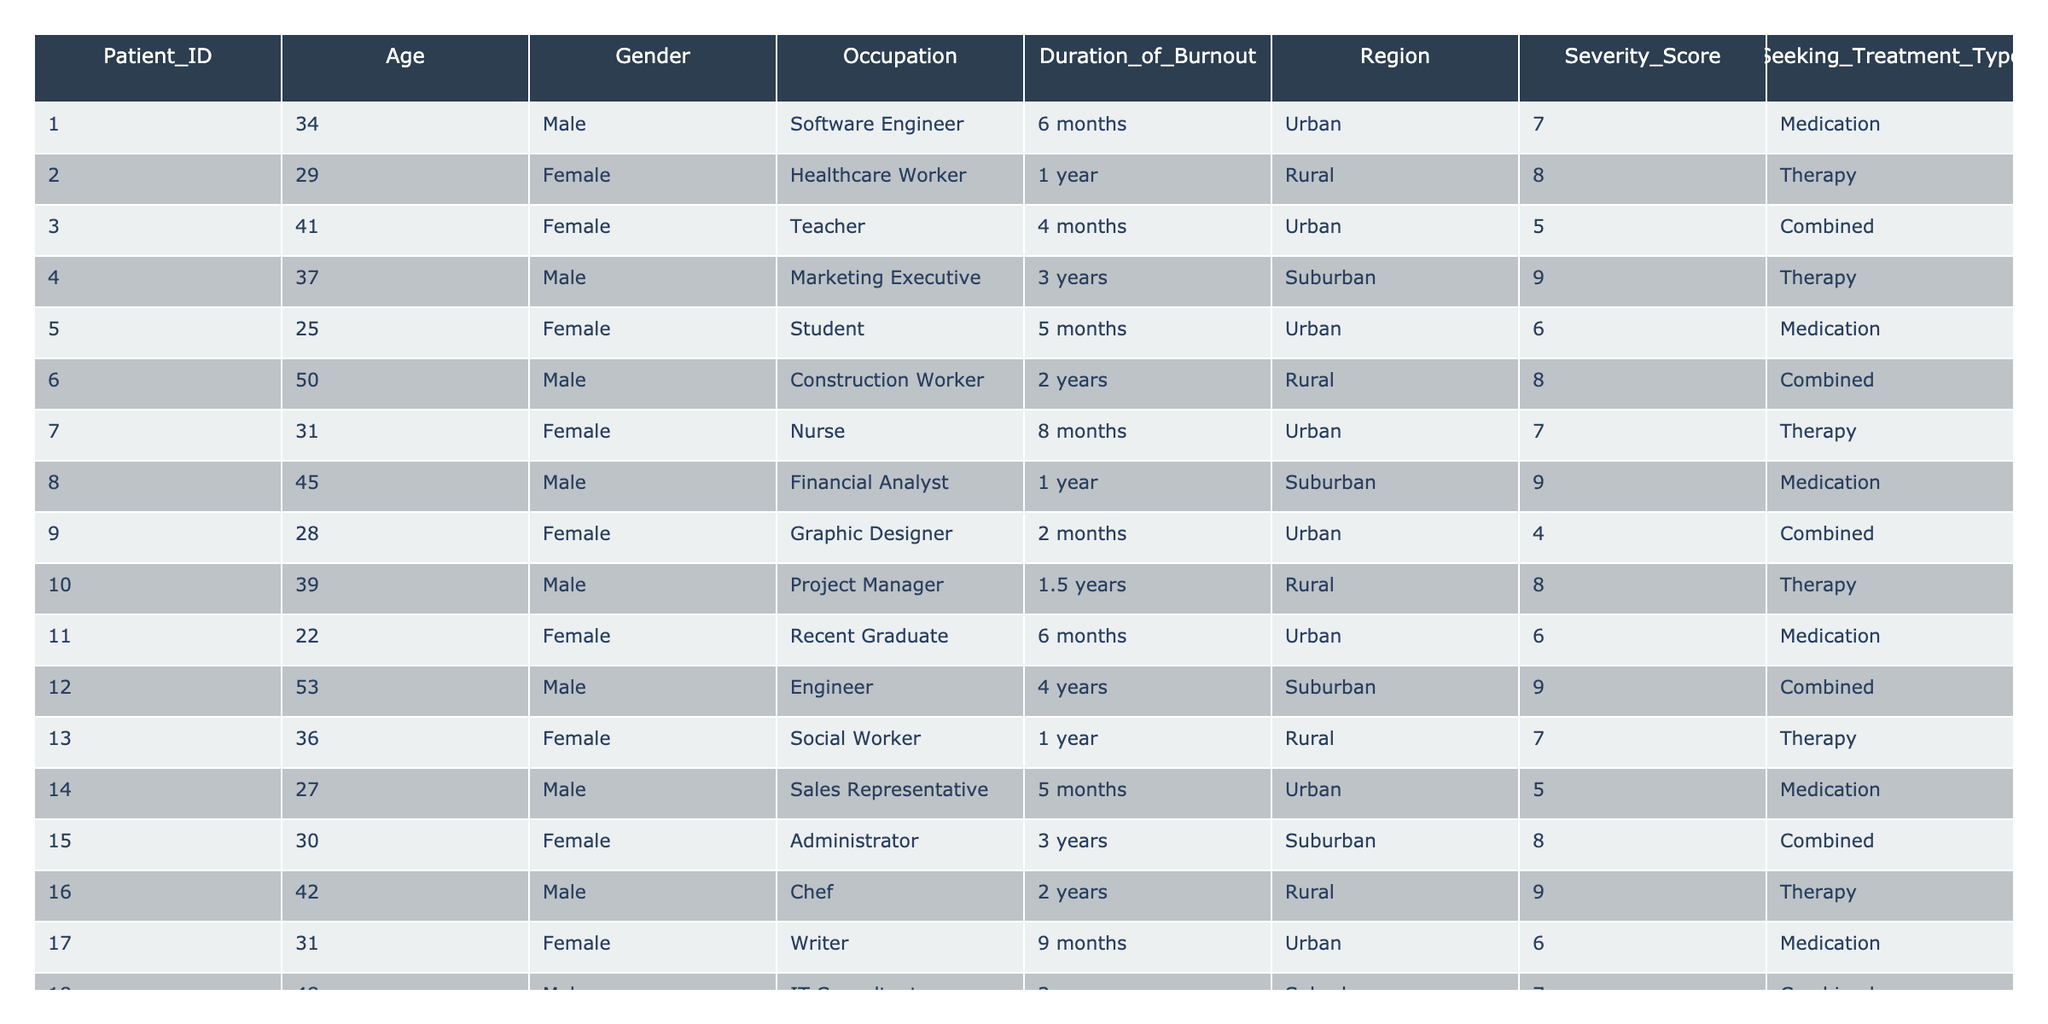What is the age of the youngest patient seeking treatment? The youngest patient is Patient_ID 11, who is 22 years old. I identified the ages in the table and determined that 22 is the lowest value.
Answer: 22 How many males are seeking medication for burnout? Looking at the table, Patients 1, 5, 14, 20 are the males listed under the 'Medication' treatment type, totaling 4 males.
Answer: 4 What is the average severity score of patients in suburban areas? The severity scores of patients from suburban areas are 9, 9, 8, 7, and 9. The average is calculated as (9 + 9 + 8 + 7 + 9) / 5 = 8.4.
Answer: 8.4 Is there any patient with a duration of burnout less than 3 months? Scanning through the duration column, I see that the shortest duration is 2 months for Patient_ID 9, confirming that such a patient does exist.
Answer: Yes Which occupation has the highest severity score among those seeking combined treatment? Among the combined treatment patients, the severity scores are 5, 9, and 7 for the occupations Student, Engineer, and IT Consultant respectively. The highest is 9 for the Engineer.
Answer: Engineer What is the total number of patients seeking therapy? Checking the table, the number of patients under 'Therapy' is 6 in total. I counted the rows where the treatment type is 'Therapy'.
Answer: 6 Do more females or males have a severity score of 9? For females, the severity score of 9 only appears once (Patient 4). For males, it appears twice (Patients 4 and 16). Therefore, more males have a severity score of 9.
Answer: Males What is the difference in average age between male and female patients? The average age for male patients is (34 + 37 + 50 + 45 + 39 + 42 + 31 + 38) / 8 = 39. The average for female patients is (29 + 41 + 25 + 31 + 22 + 36 + 30 + 26) / 8 = 30. The difference is 39 - 30 = 9.
Answer: 9 Which region has the most patients seeking treatment? I counted the number of patients from each region: Urban has 10, Rural has 5, and Suburban has 5. Urban has the highest number of patients seeking treatment.
Answer: Urban What percentage of patients are seeking combined treatment? There are 3 patients seeking combined treatment out of 20 total patients. The percentage is (3 / 20) * 100 = 15%.
Answer: 15% 